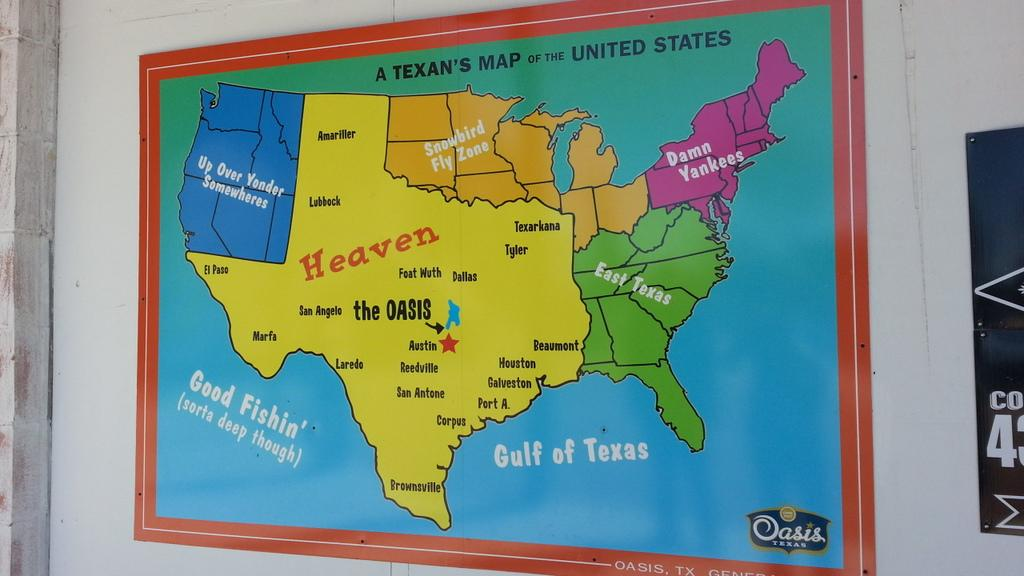<image>
Describe the image concisely. A colorful map of the United States posted on a wall. 